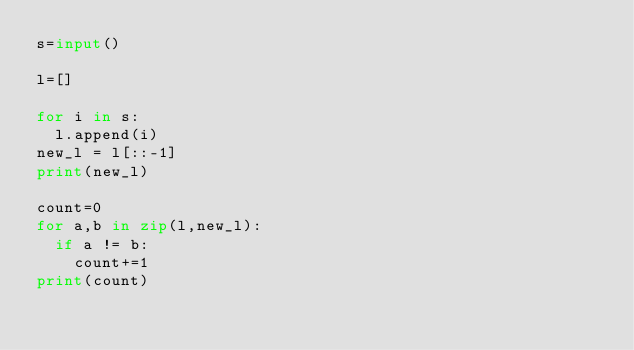Convert code to text. <code><loc_0><loc_0><loc_500><loc_500><_Python_>s=input()

l=[]

for i in s:
  l.append(i)
new_l = l[::-1]
print(new_l)

count=0
for a,b in zip(l,new_l):
  if a != b:
    count+=1
print(count)
   
  
  </code> 